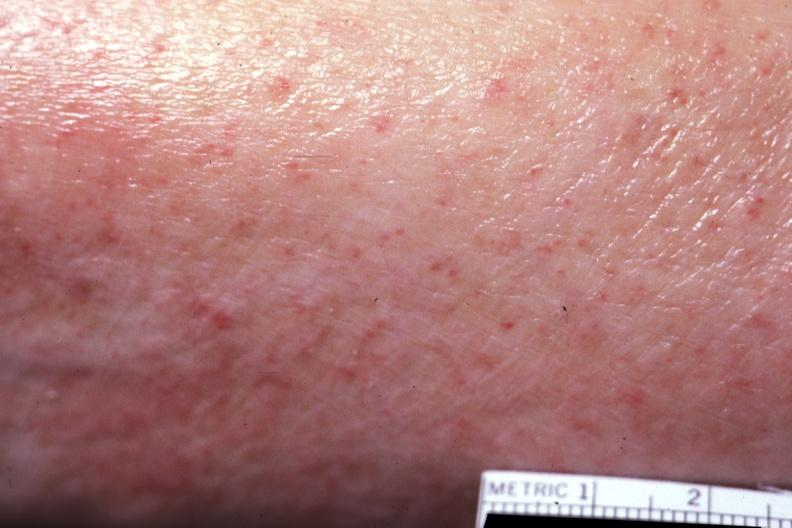where is this?
Answer the question using a single word or phrase. Skin 